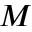<formula> <loc_0><loc_0><loc_500><loc_500>M</formula> 